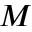<formula> <loc_0><loc_0><loc_500><loc_500>M</formula> 